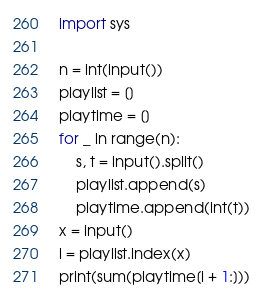Convert code to text. <code><loc_0><loc_0><loc_500><loc_500><_Python_>import sys

n = int(input())
playlist = []
playtime = []
for _ in range(n):
    s, t = input().split()
    playlist.append(s)
    playtime.append(int(t))
x = input()
i = playlist.index(x)
print(sum(playtime[i + 1:]))
</code> 